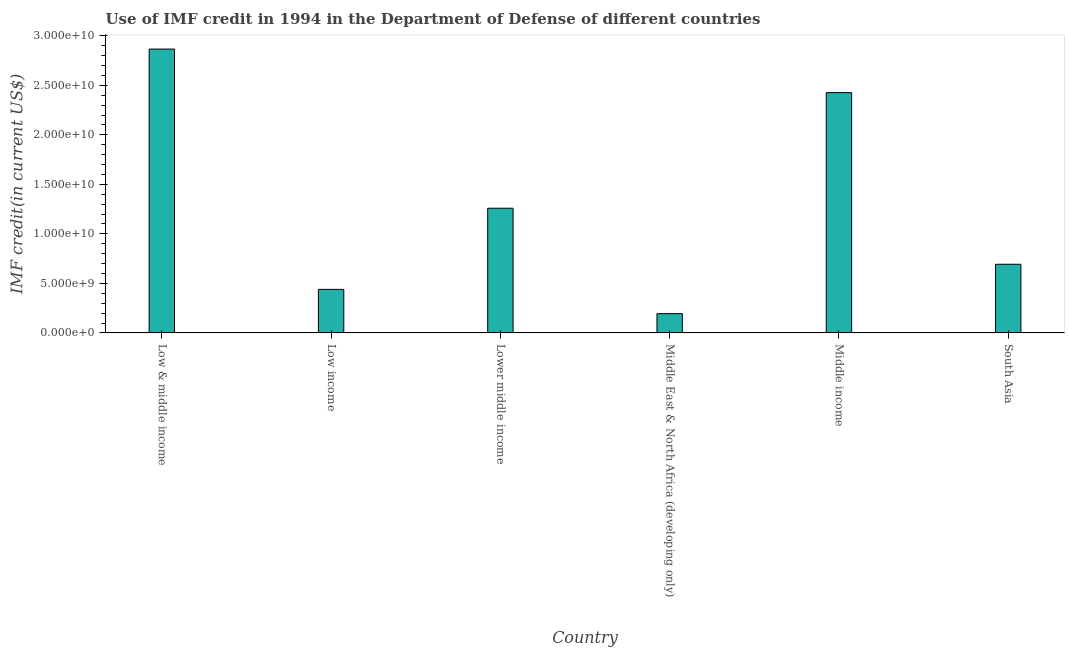Does the graph contain any zero values?
Provide a succinct answer. No. What is the title of the graph?
Give a very brief answer. Use of IMF credit in 1994 in the Department of Defense of different countries. What is the label or title of the Y-axis?
Your answer should be compact. IMF credit(in current US$). What is the use of imf credit in dod in Lower middle income?
Provide a short and direct response. 1.26e+1. Across all countries, what is the maximum use of imf credit in dod?
Offer a terse response. 2.87e+1. Across all countries, what is the minimum use of imf credit in dod?
Ensure brevity in your answer.  1.95e+09. In which country was the use of imf credit in dod maximum?
Keep it short and to the point. Low & middle income. In which country was the use of imf credit in dod minimum?
Your response must be concise. Middle East & North Africa (developing only). What is the sum of the use of imf credit in dod?
Your response must be concise. 7.88e+1. What is the difference between the use of imf credit in dod in Low & middle income and South Asia?
Keep it short and to the point. 2.17e+1. What is the average use of imf credit in dod per country?
Ensure brevity in your answer.  1.31e+1. What is the median use of imf credit in dod?
Your answer should be compact. 9.76e+09. In how many countries, is the use of imf credit in dod greater than 4000000000 US$?
Your answer should be very brief. 5. What is the ratio of the use of imf credit in dod in Low & middle income to that in Low income?
Make the answer very short. 6.52. Is the use of imf credit in dod in Low income less than that in Middle East & North Africa (developing only)?
Your answer should be compact. No. What is the difference between the highest and the second highest use of imf credit in dod?
Offer a terse response. 4.40e+09. What is the difference between the highest and the lowest use of imf credit in dod?
Make the answer very short. 2.67e+1. In how many countries, is the use of imf credit in dod greater than the average use of imf credit in dod taken over all countries?
Offer a very short reply. 2. How many bars are there?
Offer a terse response. 6. What is the IMF credit(in current US$) of Low & middle income?
Offer a very short reply. 2.87e+1. What is the IMF credit(in current US$) in Low income?
Offer a terse response. 4.40e+09. What is the IMF credit(in current US$) of Lower middle income?
Your answer should be compact. 1.26e+1. What is the IMF credit(in current US$) of Middle East & North Africa (developing only)?
Your response must be concise. 1.95e+09. What is the IMF credit(in current US$) of Middle income?
Your answer should be very brief. 2.43e+1. What is the IMF credit(in current US$) in South Asia?
Offer a very short reply. 6.93e+09. What is the difference between the IMF credit(in current US$) in Low & middle income and Low income?
Provide a succinct answer. 2.43e+1. What is the difference between the IMF credit(in current US$) in Low & middle income and Lower middle income?
Offer a terse response. 1.61e+1. What is the difference between the IMF credit(in current US$) in Low & middle income and Middle East & North Africa (developing only)?
Offer a terse response. 2.67e+1. What is the difference between the IMF credit(in current US$) in Low & middle income and Middle income?
Offer a terse response. 4.40e+09. What is the difference between the IMF credit(in current US$) in Low & middle income and South Asia?
Your answer should be very brief. 2.17e+1. What is the difference between the IMF credit(in current US$) in Low income and Lower middle income?
Your answer should be very brief. -8.19e+09. What is the difference between the IMF credit(in current US$) in Low income and Middle East & North Africa (developing only)?
Your response must be concise. 2.45e+09. What is the difference between the IMF credit(in current US$) in Low income and Middle income?
Offer a very short reply. -1.99e+1. What is the difference between the IMF credit(in current US$) in Low income and South Asia?
Offer a terse response. -2.54e+09. What is the difference between the IMF credit(in current US$) in Lower middle income and Middle East & North Africa (developing only)?
Make the answer very short. 1.06e+1. What is the difference between the IMF credit(in current US$) in Lower middle income and Middle income?
Keep it short and to the point. -1.17e+1. What is the difference between the IMF credit(in current US$) in Lower middle income and South Asia?
Ensure brevity in your answer.  5.66e+09. What is the difference between the IMF credit(in current US$) in Middle East & North Africa (developing only) and Middle income?
Make the answer very short. -2.23e+1. What is the difference between the IMF credit(in current US$) in Middle East & North Africa (developing only) and South Asia?
Give a very brief answer. -4.99e+09. What is the difference between the IMF credit(in current US$) in Middle income and South Asia?
Ensure brevity in your answer.  1.73e+1. What is the ratio of the IMF credit(in current US$) in Low & middle income to that in Low income?
Make the answer very short. 6.52. What is the ratio of the IMF credit(in current US$) in Low & middle income to that in Lower middle income?
Keep it short and to the point. 2.28. What is the ratio of the IMF credit(in current US$) in Low & middle income to that in Middle East & North Africa (developing only)?
Provide a short and direct response. 14.72. What is the ratio of the IMF credit(in current US$) in Low & middle income to that in Middle income?
Provide a short and direct response. 1.18. What is the ratio of the IMF credit(in current US$) in Low & middle income to that in South Asia?
Ensure brevity in your answer.  4.13. What is the ratio of the IMF credit(in current US$) in Low income to that in Lower middle income?
Your answer should be compact. 0.35. What is the ratio of the IMF credit(in current US$) in Low income to that in Middle East & North Africa (developing only)?
Make the answer very short. 2.26. What is the ratio of the IMF credit(in current US$) in Low income to that in Middle income?
Your answer should be very brief. 0.18. What is the ratio of the IMF credit(in current US$) in Low income to that in South Asia?
Make the answer very short. 0.63. What is the ratio of the IMF credit(in current US$) in Lower middle income to that in Middle East & North Africa (developing only)?
Your response must be concise. 6.47. What is the ratio of the IMF credit(in current US$) in Lower middle income to that in Middle income?
Offer a very short reply. 0.52. What is the ratio of the IMF credit(in current US$) in Lower middle income to that in South Asia?
Offer a terse response. 1.82. What is the ratio of the IMF credit(in current US$) in Middle East & North Africa (developing only) to that in South Asia?
Offer a terse response. 0.28. 